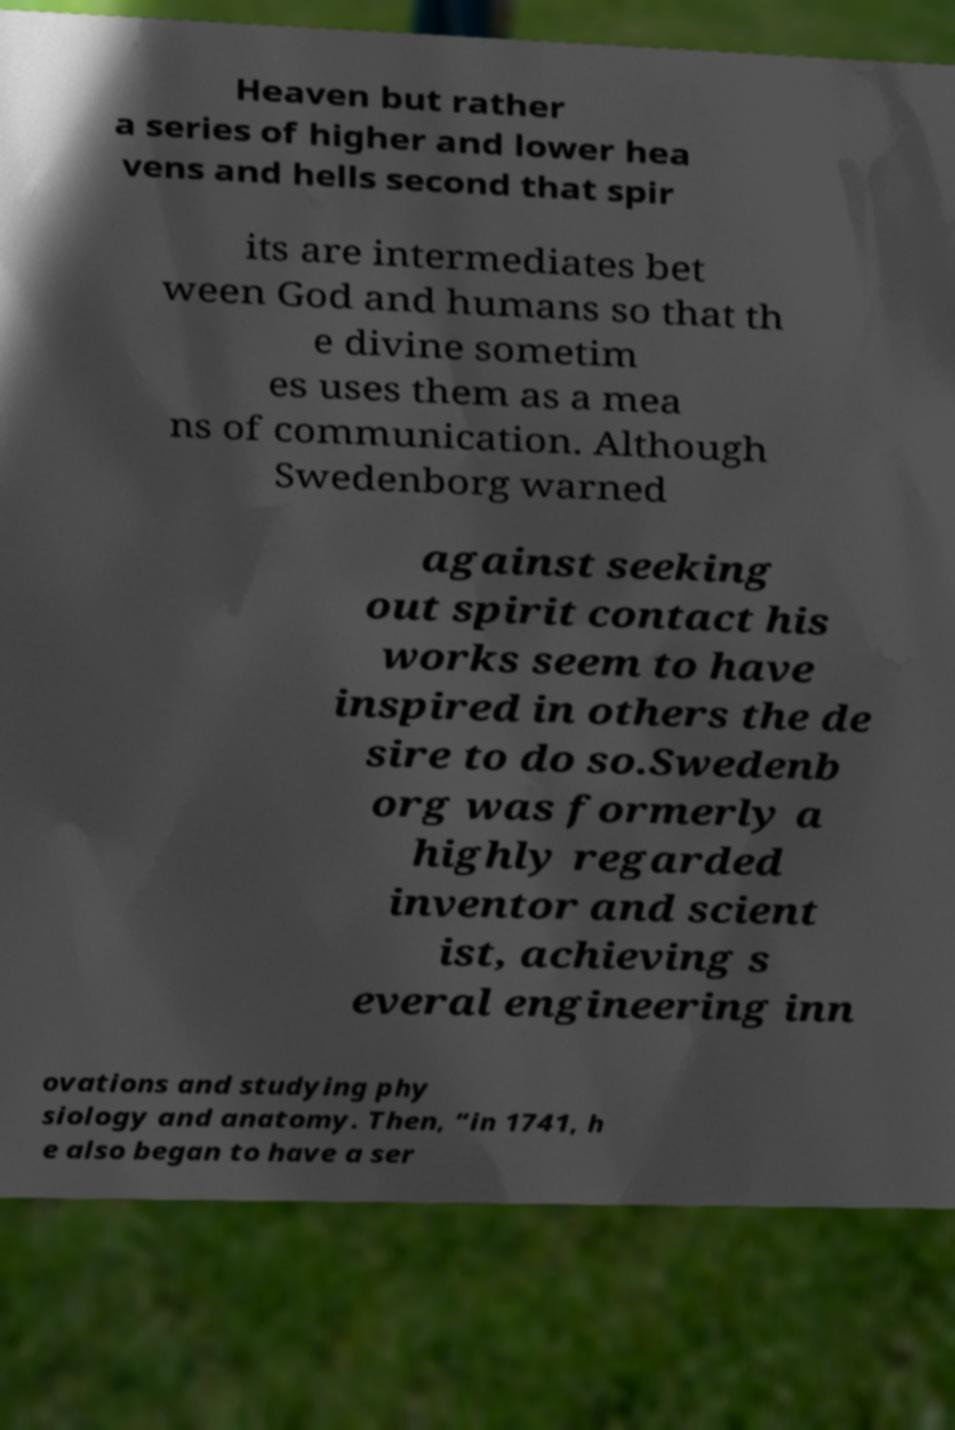There's text embedded in this image that I need extracted. Can you transcribe it verbatim? Heaven but rather a series of higher and lower hea vens and hells second that spir its are intermediates bet ween God and humans so that th e divine sometim es uses them as a mea ns of communication. Although Swedenborg warned against seeking out spirit contact his works seem to have inspired in others the de sire to do so.Swedenb org was formerly a highly regarded inventor and scient ist, achieving s everal engineering inn ovations and studying phy siology and anatomy. Then, “in 1741, h e also began to have a ser 